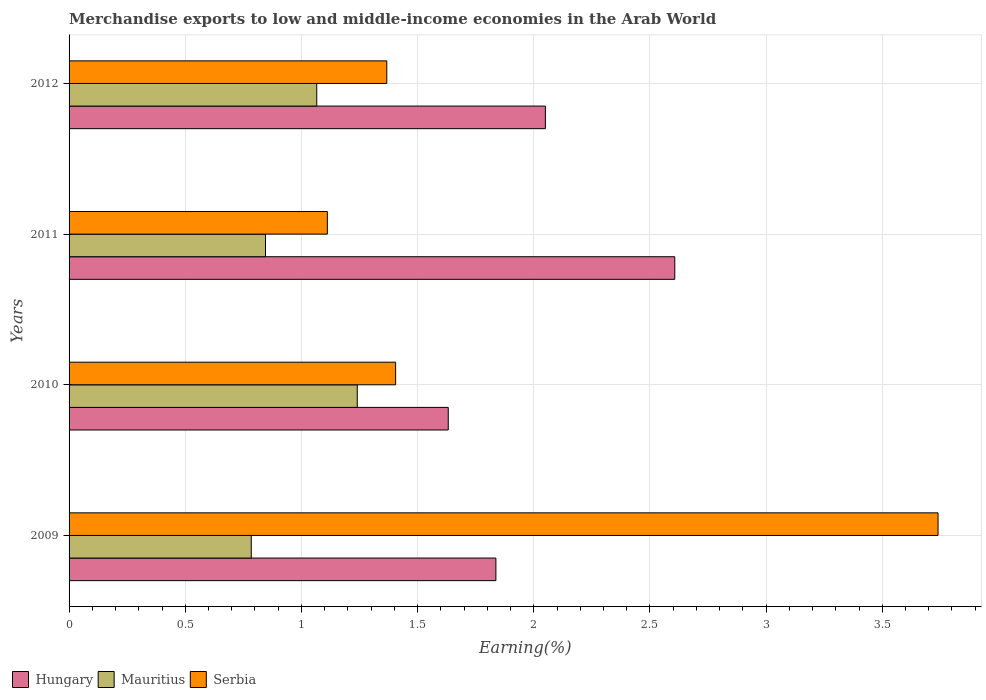How many different coloured bars are there?
Offer a terse response. 3. Are the number of bars on each tick of the Y-axis equal?
Offer a terse response. Yes. What is the label of the 3rd group of bars from the top?
Keep it short and to the point. 2010. In how many cases, is the number of bars for a given year not equal to the number of legend labels?
Make the answer very short. 0. What is the percentage of amount earned from merchandise exports in Mauritius in 2011?
Provide a short and direct response. 0.85. Across all years, what is the maximum percentage of amount earned from merchandise exports in Hungary?
Offer a very short reply. 2.61. Across all years, what is the minimum percentage of amount earned from merchandise exports in Serbia?
Your answer should be compact. 1.11. In which year was the percentage of amount earned from merchandise exports in Hungary minimum?
Ensure brevity in your answer.  2010. What is the total percentage of amount earned from merchandise exports in Mauritius in the graph?
Offer a very short reply. 3.94. What is the difference between the percentage of amount earned from merchandise exports in Serbia in 2010 and that in 2012?
Your answer should be compact. 0.04. What is the difference between the percentage of amount earned from merchandise exports in Hungary in 2010 and the percentage of amount earned from merchandise exports in Mauritius in 2009?
Provide a succinct answer. 0.85. What is the average percentage of amount earned from merchandise exports in Serbia per year?
Your answer should be compact. 1.91. In the year 2012, what is the difference between the percentage of amount earned from merchandise exports in Mauritius and percentage of amount earned from merchandise exports in Serbia?
Offer a terse response. -0.3. What is the ratio of the percentage of amount earned from merchandise exports in Mauritius in 2011 to that in 2012?
Provide a short and direct response. 0.79. What is the difference between the highest and the second highest percentage of amount earned from merchandise exports in Mauritius?
Keep it short and to the point. 0.17. What is the difference between the highest and the lowest percentage of amount earned from merchandise exports in Hungary?
Your answer should be very brief. 0.97. What does the 1st bar from the top in 2010 represents?
Give a very brief answer. Serbia. What does the 3rd bar from the bottom in 2010 represents?
Offer a terse response. Serbia. Is it the case that in every year, the sum of the percentage of amount earned from merchandise exports in Serbia and percentage of amount earned from merchandise exports in Mauritius is greater than the percentage of amount earned from merchandise exports in Hungary?
Provide a short and direct response. No. How many bars are there?
Provide a short and direct response. 12. Does the graph contain any zero values?
Your answer should be very brief. No. Where does the legend appear in the graph?
Ensure brevity in your answer.  Bottom left. How many legend labels are there?
Offer a very short reply. 3. What is the title of the graph?
Your answer should be very brief. Merchandise exports to low and middle-income economies in the Arab World. What is the label or title of the X-axis?
Offer a terse response. Earning(%). What is the Earning(%) of Hungary in 2009?
Provide a short and direct response. 1.84. What is the Earning(%) of Mauritius in 2009?
Make the answer very short. 0.78. What is the Earning(%) in Serbia in 2009?
Make the answer very short. 3.74. What is the Earning(%) in Hungary in 2010?
Keep it short and to the point. 1.63. What is the Earning(%) of Mauritius in 2010?
Make the answer very short. 1.24. What is the Earning(%) of Serbia in 2010?
Your answer should be very brief. 1.41. What is the Earning(%) in Hungary in 2011?
Offer a terse response. 2.61. What is the Earning(%) of Mauritius in 2011?
Give a very brief answer. 0.85. What is the Earning(%) of Serbia in 2011?
Provide a succinct answer. 1.11. What is the Earning(%) in Hungary in 2012?
Provide a succinct answer. 2.05. What is the Earning(%) in Mauritius in 2012?
Ensure brevity in your answer.  1.07. What is the Earning(%) in Serbia in 2012?
Make the answer very short. 1.37. Across all years, what is the maximum Earning(%) in Hungary?
Your response must be concise. 2.61. Across all years, what is the maximum Earning(%) of Mauritius?
Offer a terse response. 1.24. Across all years, what is the maximum Earning(%) in Serbia?
Make the answer very short. 3.74. Across all years, what is the minimum Earning(%) of Hungary?
Offer a very short reply. 1.63. Across all years, what is the minimum Earning(%) of Mauritius?
Provide a succinct answer. 0.78. Across all years, what is the minimum Earning(%) in Serbia?
Your answer should be very brief. 1.11. What is the total Earning(%) of Hungary in the graph?
Make the answer very short. 8.13. What is the total Earning(%) of Mauritius in the graph?
Offer a very short reply. 3.94. What is the total Earning(%) of Serbia in the graph?
Offer a very short reply. 7.62. What is the difference between the Earning(%) of Hungary in 2009 and that in 2010?
Offer a terse response. 0.21. What is the difference between the Earning(%) of Mauritius in 2009 and that in 2010?
Ensure brevity in your answer.  -0.46. What is the difference between the Earning(%) in Serbia in 2009 and that in 2010?
Provide a succinct answer. 2.33. What is the difference between the Earning(%) of Hungary in 2009 and that in 2011?
Provide a succinct answer. -0.77. What is the difference between the Earning(%) of Mauritius in 2009 and that in 2011?
Provide a succinct answer. -0.06. What is the difference between the Earning(%) of Serbia in 2009 and that in 2011?
Your response must be concise. 2.63. What is the difference between the Earning(%) of Hungary in 2009 and that in 2012?
Your answer should be compact. -0.21. What is the difference between the Earning(%) of Mauritius in 2009 and that in 2012?
Keep it short and to the point. -0.28. What is the difference between the Earning(%) of Serbia in 2009 and that in 2012?
Provide a succinct answer. 2.37. What is the difference between the Earning(%) of Hungary in 2010 and that in 2011?
Provide a short and direct response. -0.97. What is the difference between the Earning(%) in Mauritius in 2010 and that in 2011?
Offer a very short reply. 0.4. What is the difference between the Earning(%) in Serbia in 2010 and that in 2011?
Provide a succinct answer. 0.29. What is the difference between the Earning(%) in Hungary in 2010 and that in 2012?
Your answer should be compact. -0.42. What is the difference between the Earning(%) in Mauritius in 2010 and that in 2012?
Make the answer very short. 0.17. What is the difference between the Earning(%) in Serbia in 2010 and that in 2012?
Offer a terse response. 0.04. What is the difference between the Earning(%) in Hungary in 2011 and that in 2012?
Keep it short and to the point. 0.56. What is the difference between the Earning(%) in Mauritius in 2011 and that in 2012?
Ensure brevity in your answer.  -0.22. What is the difference between the Earning(%) of Serbia in 2011 and that in 2012?
Make the answer very short. -0.26. What is the difference between the Earning(%) of Hungary in 2009 and the Earning(%) of Mauritius in 2010?
Ensure brevity in your answer.  0.6. What is the difference between the Earning(%) of Hungary in 2009 and the Earning(%) of Serbia in 2010?
Provide a short and direct response. 0.43. What is the difference between the Earning(%) of Mauritius in 2009 and the Earning(%) of Serbia in 2010?
Offer a very short reply. -0.62. What is the difference between the Earning(%) of Hungary in 2009 and the Earning(%) of Mauritius in 2011?
Keep it short and to the point. 0.99. What is the difference between the Earning(%) in Hungary in 2009 and the Earning(%) in Serbia in 2011?
Make the answer very short. 0.73. What is the difference between the Earning(%) in Mauritius in 2009 and the Earning(%) in Serbia in 2011?
Keep it short and to the point. -0.33. What is the difference between the Earning(%) in Hungary in 2009 and the Earning(%) in Mauritius in 2012?
Keep it short and to the point. 0.77. What is the difference between the Earning(%) of Hungary in 2009 and the Earning(%) of Serbia in 2012?
Give a very brief answer. 0.47. What is the difference between the Earning(%) of Mauritius in 2009 and the Earning(%) of Serbia in 2012?
Offer a terse response. -0.58. What is the difference between the Earning(%) in Hungary in 2010 and the Earning(%) in Mauritius in 2011?
Keep it short and to the point. 0.79. What is the difference between the Earning(%) in Hungary in 2010 and the Earning(%) in Serbia in 2011?
Offer a terse response. 0.52. What is the difference between the Earning(%) in Mauritius in 2010 and the Earning(%) in Serbia in 2011?
Provide a succinct answer. 0.13. What is the difference between the Earning(%) in Hungary in 2010 and the Earning(%) in Mauritius in 2012?
Make the answer very short. 0.57. What is the difference between the Earning(%) of Hungary in 2010 and the Earning(%) of Serbia in 2012?
Make the answer very short. 0.26. What is the difference between the Earning(%) of Mauritius in 2010 and the Earning(%) of Serbia in 2012?
Provide a short and direct response. -0.13. What is the difference between the Earning(%) of Hungary in 2011 and the Earning(%) of Mauritius in 2012?
Offer a terse response. 1.54. What is the difference between the Earning(%) of Hungary in 2011 and the Earning(%) of Serbia in 2012?
Provide a short and direct response. 1.24. What is the difference between the Earning(%) of Mauritius in 2011 and the Earning(%) of Serbia in 2012?
Make the answer very short. -0.52. What is the average Earning(%) of Hungary per year?
Ensure brevity in your answer.  2.03. What is the average Earning(%) of Mauritius per year?
Your answer should be very brief. 0.98. What is the average Earning(%) of Serbia per year?
Provide a succinct answer. 1.91. In the year 2009, what is the difference between the Earning(%) in Hungary and Earning(%) in Mauritius?
Offer a terse response. 1.05. In the year 2009, what is the difference between the Earning(%) of Hungary and Earning(%) of Serbia?
Ensure brevity in your answer.  -1.9. In the year 2009, what is the difference between the Earning(%) in Mauritius and Earning(%) in Serbia?
Your answer should be compact. -2.96. In the year 2010, what is the difference between the Earning(%) in Hungary and Earning(%) in Mauritius?
Your answer should be compact. 0.39. In the year 2010, what is the difference between the Earning(%) of Hungary and Earning(%) of Serbia?
Ensure brevity in your answer.  0.23. In the year 2010, what is the difference between the Earning(%) of Mauritius and Earning(%) of Serbia?
Ensure brevity in your answer.  -0.17. In the year 2011, what is the difference between the Earning(%) in Hungary and Earning(%) in Mauritius?
Ensure brevity in your answer.  1.76. In the year 2011, what is the difference between the Earning(%) in Hungary and Earning(%) in Serbia?
Ensure brevity in your answer.  1.5. In the year 2011, what is the difference between the Earning(%) of Mauritius and Earning(%) of Serbia?
Provide a short and direct response. -0.27. In the year 2012, what is the difference between the Earning(%) of Hungary and Earning(%) of Mauritius?
Ensure brevity in your answer.  0.98. In the year 2012, what is the difference between the Earning(%) of Hungary and Earning(%) of Serbia?
Offer a very short reply. 0.68. In the year 2012, what is the difference between the Earning(%) of Mauritius and Earning(%) of Serbia?
Your answer should be very brief. -0.3. What is the ratio of the Earning(%) of Hungary in 2009 to that in 2010?
Give a very brief answer. 1.13. What is the ratio of the Earning(%) in Mauritius in 2009 to that in 2010?
Give a very brief answer. 0.63. What is the ratio of the Earning(%) in Serbia in 2009 to that in 2010?
Make the answer very short. 2.66. What is the ratio of the Earning(%) of Hungary in 2009 to that in 2011?
Your response must be concise. 0.7. What is the ratio of the Earning(%) in Mauritius in 2009 to that in 2011?
Ensure brevity in your answer.  0.93. What is the ratio of the Earning(%) of Serbia in 2009 to that in 2011?
Your response must be concise. 3.36. What is the ratio of the Earning(%) of Hungary in 2009 to that in 2012?
Ensure brevity in your answer.  0.9. What is the ratio of the Earning(%) in Mauritius in 2009 to that in 2012?
Give a very brief answer. 0.74. What is the ratio of the Earning(%) in Serbia in 2009 to that in 2012?
Give a very brief answer. 2.74. What is the ratio of the Earning(%) in Hungary in 2010 to that in 2011?
Keep it short and to the point. 0.63. What is the ratio of the Earning(%) in Mauritius in 2010 to that in 2011?
Your answer should be compact. 1.47. What is the ratio of the Earning(%) of Serbia in 2010 to that in 2011?
Offer a terse response. 1.26. What is the ratio of the Earning(%) in Hungary in 2010 to that in 2012?
Provide a succinct answer. 0.8. What is the ratio of the Earning(%) in Mauritius in 2010 to that in 2012?
Your answer should be compact. 1.16. What is the ratio of the Earning(%) in Serbia in 2010 to that in 2012?
Ensure brevity in your answer.  1.03. What is the ratio of the Earning(%) in Hungary in 2011 to that in 2012?
Make the answer very short. 1.27. What is the ratio of the Earning(%) in Mauritius in 2011 to that in 2012?
Offer a terse response. 0.79. What is the ratio of the Earning(%) of Serbia in 2011 to that in 2012?
Make the answer very short. 0.81. What is the difference between the highest and the second highest Earning(%) of Hungary?
Offer a terse response. 0.56. What is the difference between the highest and the second highest Earning(%) of Mauritius?
Provide a short and direct response. 0.17. What is the difference between the highest and the second highest Earning(%) of Serbia?
Offer a terse response. 2.33. What is the difference between the highest and the lowest Earning(%) in Mauritius?
Make the answer very short. 0.46. What is the difference between the highest and the lowest Earning(%) in Serbia?
Make the answer very short. 2.63. 